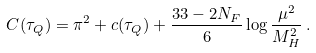<formula> <loc_0><loc_0><loc_500><loc_500>C ( \tau _ { Q } ) = \pi ^ { 2 } + c ( \tau _ { Q } ) + \frac { 3 3 - 2 N _ { F } } { 6 } \log \frac { \mu ^ { 2 } } { M _ { H } ^ { 2 } } \, .</formula> 